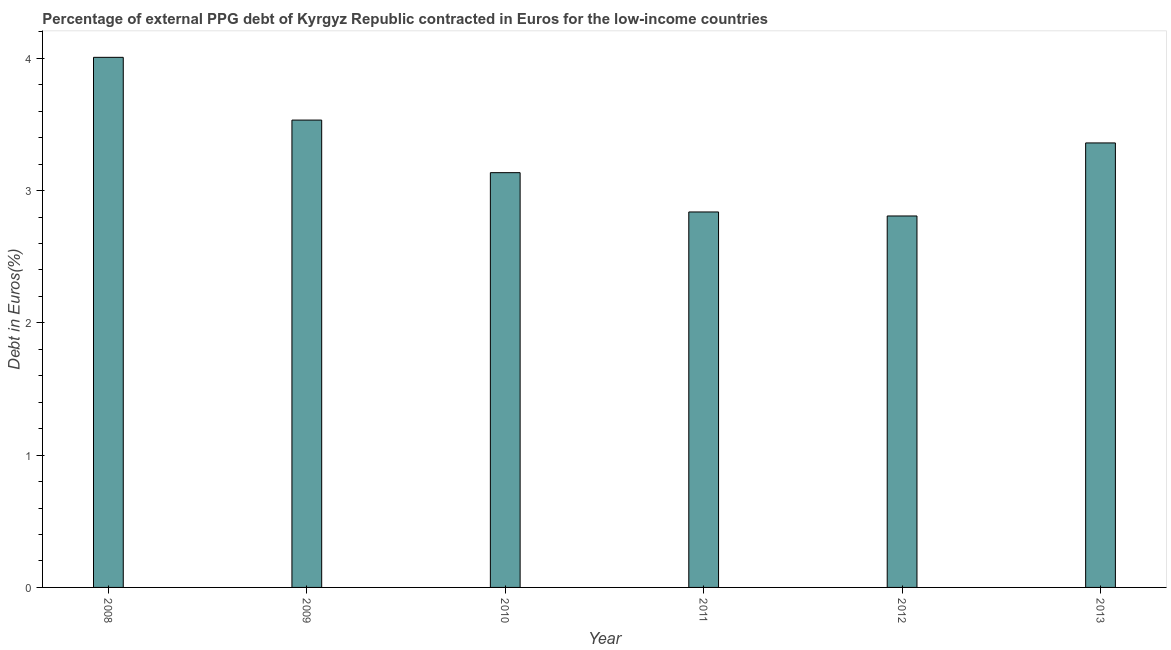Does the graph contain grids?
Provide a succinct answer. No. What is the title of the graph?
Your answer should be compact. Percentage of external PPG debt of Kyrgyz Republic contracted in Euros for the low-income countries. What is the label or title of the Y-axis?
Your response must be concise. Debt in Euros(%). What is the currency composition of ppg debt in 2010?
Make the answer very short. 3.14. Across all years, what is the maximum currency composition of ppg debt?
Your answer should be compact. 4.01. Across all years, what is the minimum currency composition of ppg debt?
Ensure brevity in your answer.  2.81. In which year was the currency composition of ppg debt minimum?
Make the answer very short. 2012. What is the sum of the currency composition of ppg debt?
Make the answer very short. 19.68. What is the difference between the currency composition of ppg debt in 2008 and 2013?
Your answer should be compact. 0.65. What is the average currency composition of ppg debt per year?
Offer a very short reply. 3.28. What is the median currency composition of ppg debt?
Keep it short and to the point. 3.25. In how many years, is the currency composition of ppg debt greater than 2.2 %?
Keep it short and to the point. 6. Do a majority of the years between 2008 and 2013 (inclusive) have currency composition of ppg debt greater than 3.6 %?
Your answer should be very brief. No. What is the ratio of the currency composition of ppg debt in 2009 to that in 2012?
Keep it short and to the point. 1.26. What is the difference between the highest and the second highest currency composition of ppg debt?
Provide a succinct answer. 0.47. What is the difference between the highest and the lowest currency composition of ppg debt?
Provide a succinct answer. 1.2. In how many years, is the currency composition of ppg debt greater than the average currency composition of ppg debt taken over all years?
Provide a succinct answer. 3. Are all the bars in the graph horizontal?
Keep it short and to the point. No. Are the values on the major ticks of Y-axis written in scientific E-notation?
Your answer should be very brief. No. What is the Debt in Euros(%) of 2008?
Your response must be concise. 4.01. What is the Debt in Euros(%) of 2009?
Your response must be concise. 3.53. What is the Debt in Euros(%) in 2010?
Offer a very short reply. 3.14. What is the Debt in Euros(%) in 2011?
Provide a short and direct response. 2.84. What is the Debt in Euros(%) of 2012?
Keep it short and to the point. 2.81. What is the Debt in Euros(%) of 2013?
Ensure brevity in your answer.  3.36. What is the difference between the Debt in Euros(%) in 2008 and 2009?
Your answer should be very brief. 0.47. What is the difference between the Debt in Euros(%) in 2008 and 2010?
Provide a short and direct response. 0.87. What is the difference between the Debt in Euros(%) in 2008 and 2011?
Your answer should be compact. 1.17. What is the difference between the Debt in Euros(%) in 2008 and 2012?
Give a very brief answer. 1.2. What is the difference between the Debt in Euros(%) in 2008 and 2013?
Offer a terse response. 0.65. What is the difference between the Debt in Euros(%) in 2009 and 2010?
Your response must be concise. 0.4. What is the difference between the Debt in Euros(%) in 2009 and 2011?
Keep it short and to the point. 0.69. What is the difference between the Debt in Euros(%) in 2009 and 2012?
Keep it short and to the point. 0.72. What is the difference between the Debt in Euros(%) in 2009 and 2013?
Your response must be concise. 0.17. What is the difference between the Debt in Euros(%) in 2010 and 2011?
Provide a succinct answer. 0.3. What is the difference between the Debt in Euros(%) in 2010 and 2012?
Provide a short and direct response. 0.33. What is the difference between the Debt in Euros(%) in 2010 and 2013?
Your response must be concise. -0.22. What is the difference between the Debt in Euros(%) in 2011 and 2012?
Keep it short and to the point. 0.03. What is the difference between the Debt in Euros(%) in 2011 and 2013?
Provide a succinct answer. -0.52. What is the difference between the Debt in Euros(%) in 2012 and 2013?
Provide a succinct answer. -0.55. What is the ratio of the Debt in Euros(%) in 2008 to that in 2009?
Ensure brevity in your answer.  1.13. What is the ratio of the Debt in Euros(%) in 2008 to that in 2010?
Make the answer very short. 1.28. What is the ratio of the Debt in Euros(%) in 2008 to that in 2011?
Your answer should be very brief. 1.41. What is the ratio of the Debt in Euros(%) in 2008 to that in 2012?
Provide a succinct answer. 1.43. What is the ratio of the Debt in Euros(%) in 2008 to that in 2013?
Keep it short and to the point. 1.19. What is the ratio of the Debt in Euros(%) in 2009 to that in 2010?
Offer a terse response. 1.13. What is the ratio of the Debt in Euros(%) in 2009 to that in 2011?
Your response must be concise. 1.25. What is the ratio of the Debt in Euros(%) in 2009 to that in 2012?
Give a very brief answer. 1.26. What is the ratio of the Debt in Euros(%) in 2009 to that in 2013?
Keep it short and to the point. 1.05. What is the ratio of the Debt in Euros(%) in 2010 to that in 2011?
Your answer should be compact. 1.1. What is the ratio of the Debt in Euros(%) in 2010 to that in 2012?
Ensure brevity in your answer.  1.12. What is the ratio of the Debt in Euros(%) in 2010 to that in 2013?
Keep it short and to the point. 0.93. What is the ratio of the Debt in Euros(%) in 2011 to that in 2012?
Give a very brief answer. 1.01. What is the ratio of the Debt in Euros(%) in 2011 to that in 2013?
Make the answer very short. 0.84. What is the ratio of the Debt in Euros(%) in 2012 to that in 2013?
Offer a terse response. 0.84. 